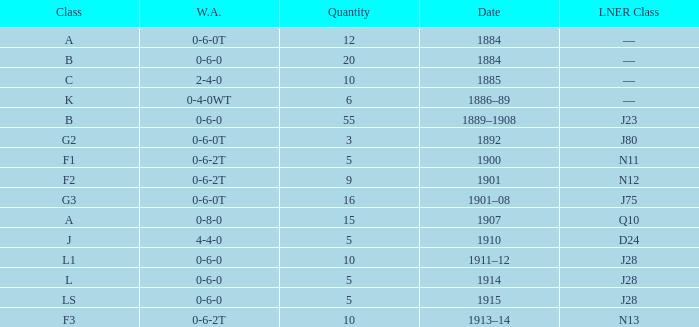What wa features an lner class of n13 and 10? 0-6-2T. 